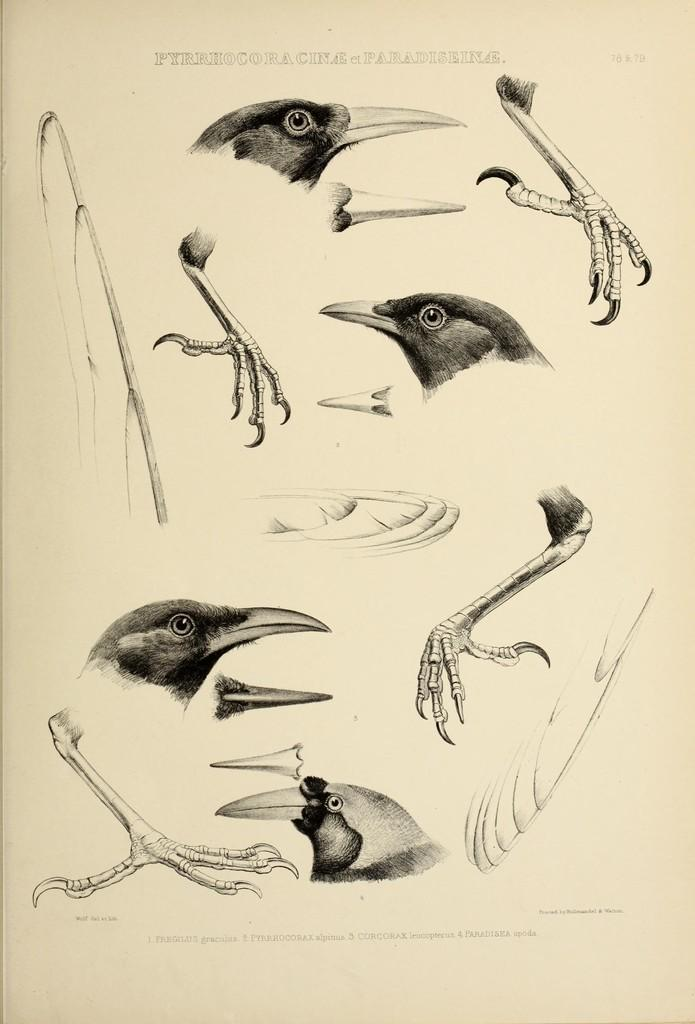What type of animals are in the image? There are birds in the image. What parts of the birds can be seen in the image? The image contains bird feathers and bird claws. How is the image created? The image is a drawing. What type of cap is the grandmother wearing in the image? There is no grandmother or cap present in the image; it only contains birds and their features. 